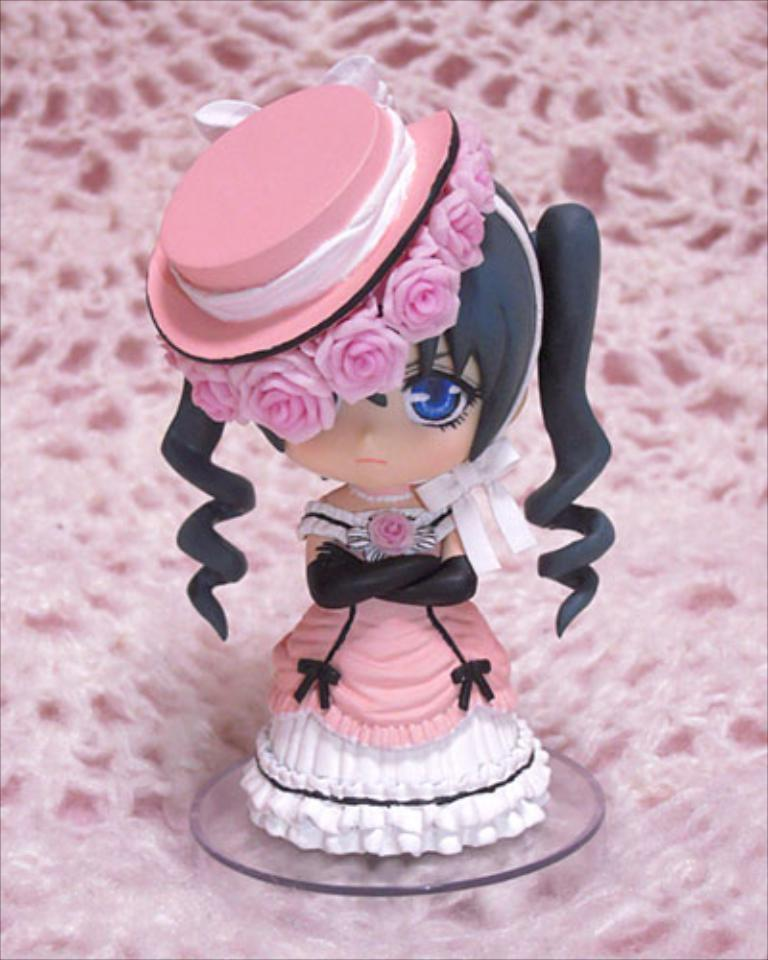What is the main subject of the image? There is a doll in the image. What is located at the bottom of the image? There is a cloth at the bottom of the image. What type of underwear is the doll wearing in the image? The image does not show the doll wearing any underwear, and therefore it cannot be determined from the image. 